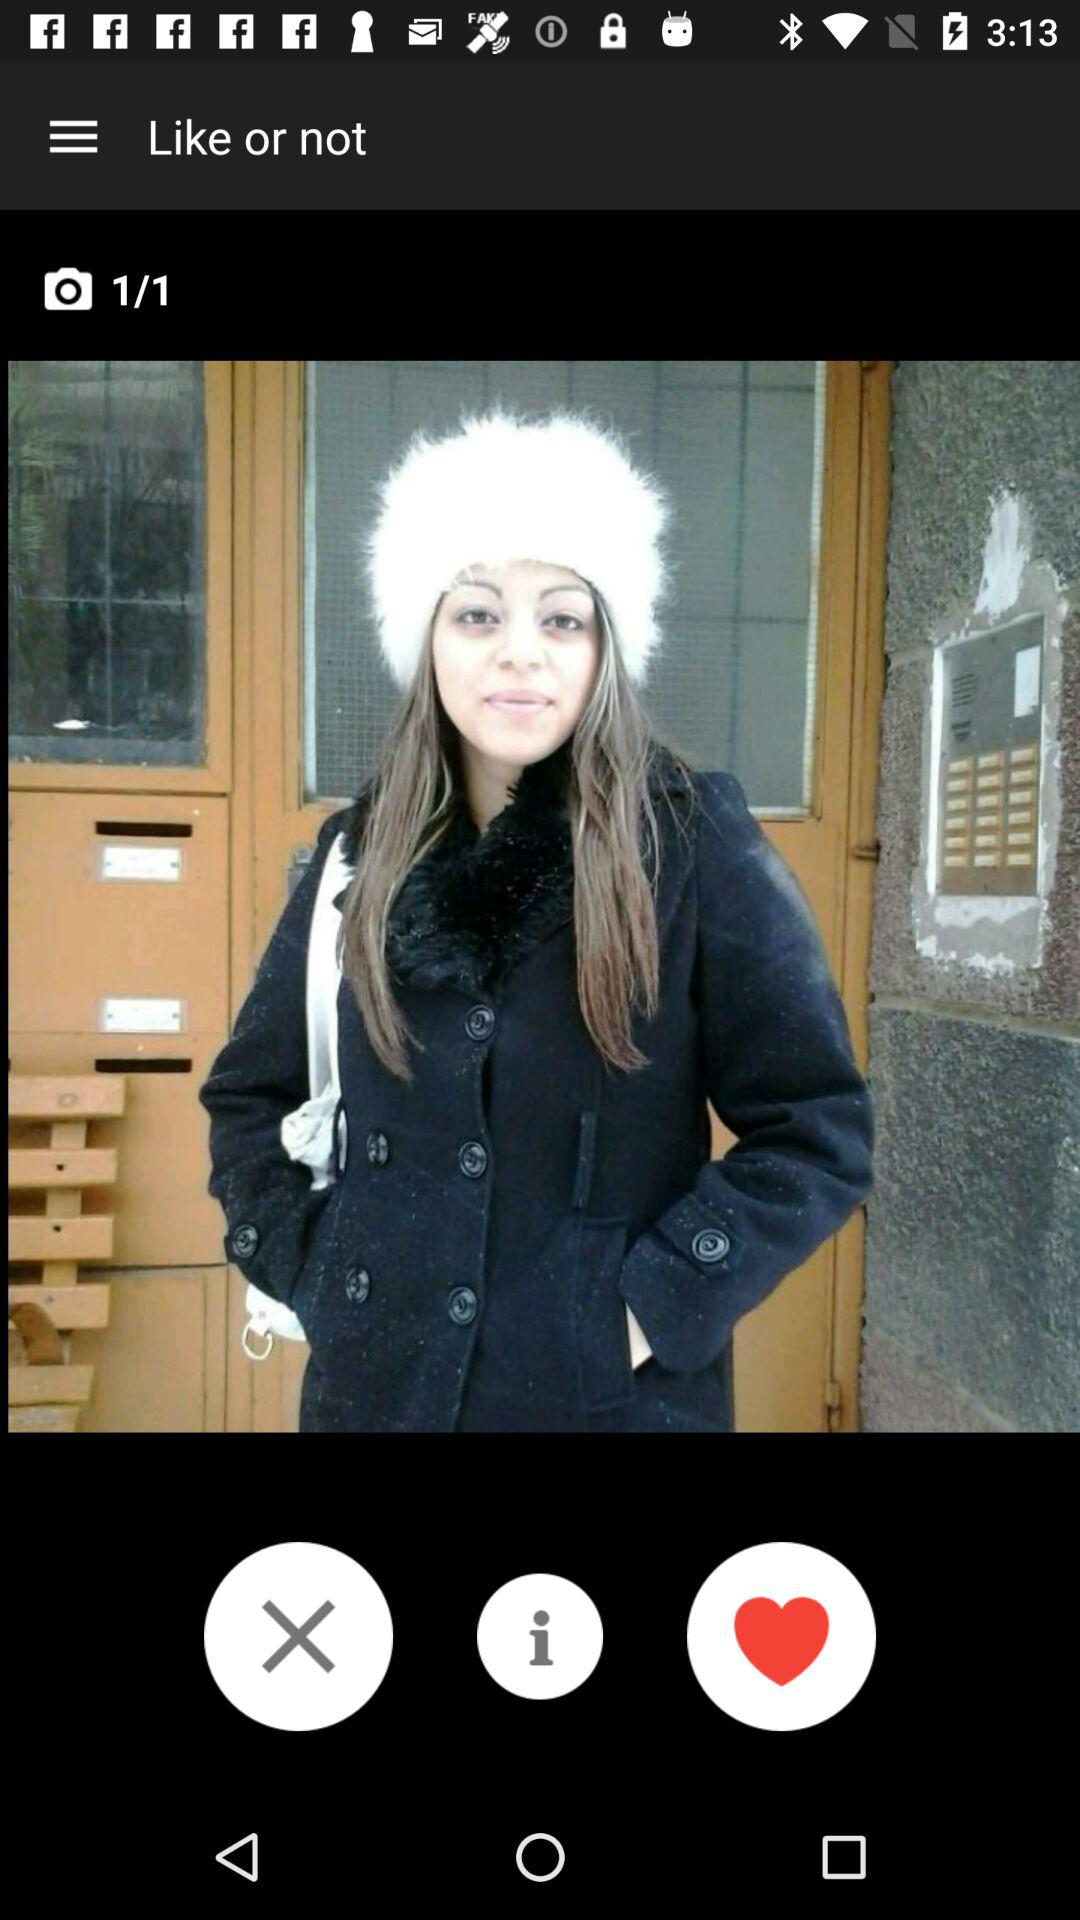At which image am I? You are at image 1. 